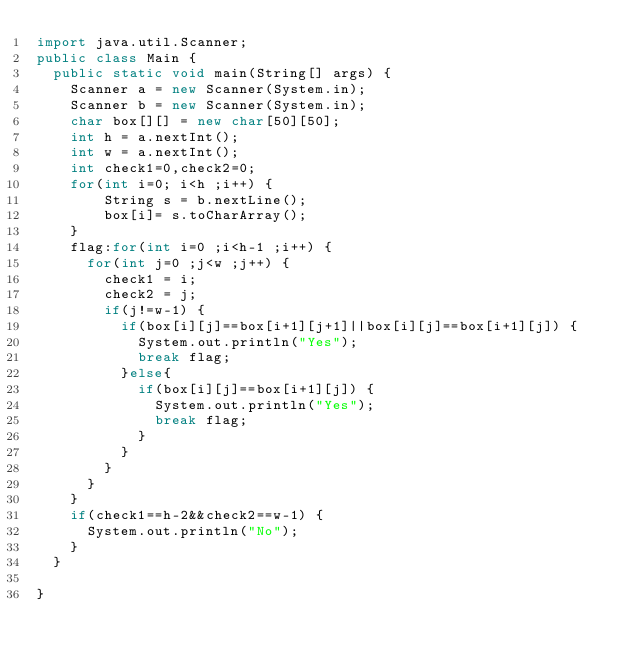<code> <loc_0><loc_0><loc_500><loc_500><_Java_>import java.util.Scanner;
public class Main {
	public static void main(String[] args) {
		Scanner a = new Scanner(System.in);
		Scanner b = new Scanner(System.in);
		char box[][] = new char[50][50];
		int h = a.nextInt();
		int w = a.nextInt();
		int check1=0,check2=0;
		for(int i=0; i<h ;i++) {
				String s = b.nextLine();
				box[i]= s.toCharArray();
		}
		flag:for(int i=0 ;i<h-1 ;i++) {
			for(int j=0 ;j<w ;j++) {
				check1 = i;
				check2 = j;
				if(j!=w-1) {
					if(box[i][j]==box[i+1][j+1]||box[i][j]==box[i+1][j]) {
						System.out.println("Yes");
						break flag;
					}else{
						if(box[i][j]==box[i+1][j]) {
							System.out.println("Yes");
							break flag;
						}
					}
				}
			}
		}
		if(check1==h-2&&check2==w-1) {
			System.out.println("No");
		}
	}

}
</code> 